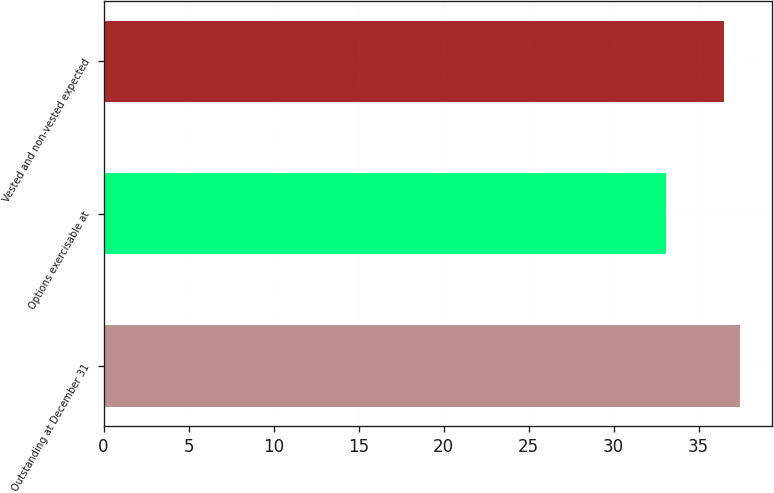<chart> <loc_0><loc_0><loc_500><loc_500><bar_chart><fcel>Outstanding at December 31<fcel>Options exercisable at<fcel>Vested and non-vested expected<nl><fcel>37.44<fcel>33.07<fcel>36.52<nl></chart> 